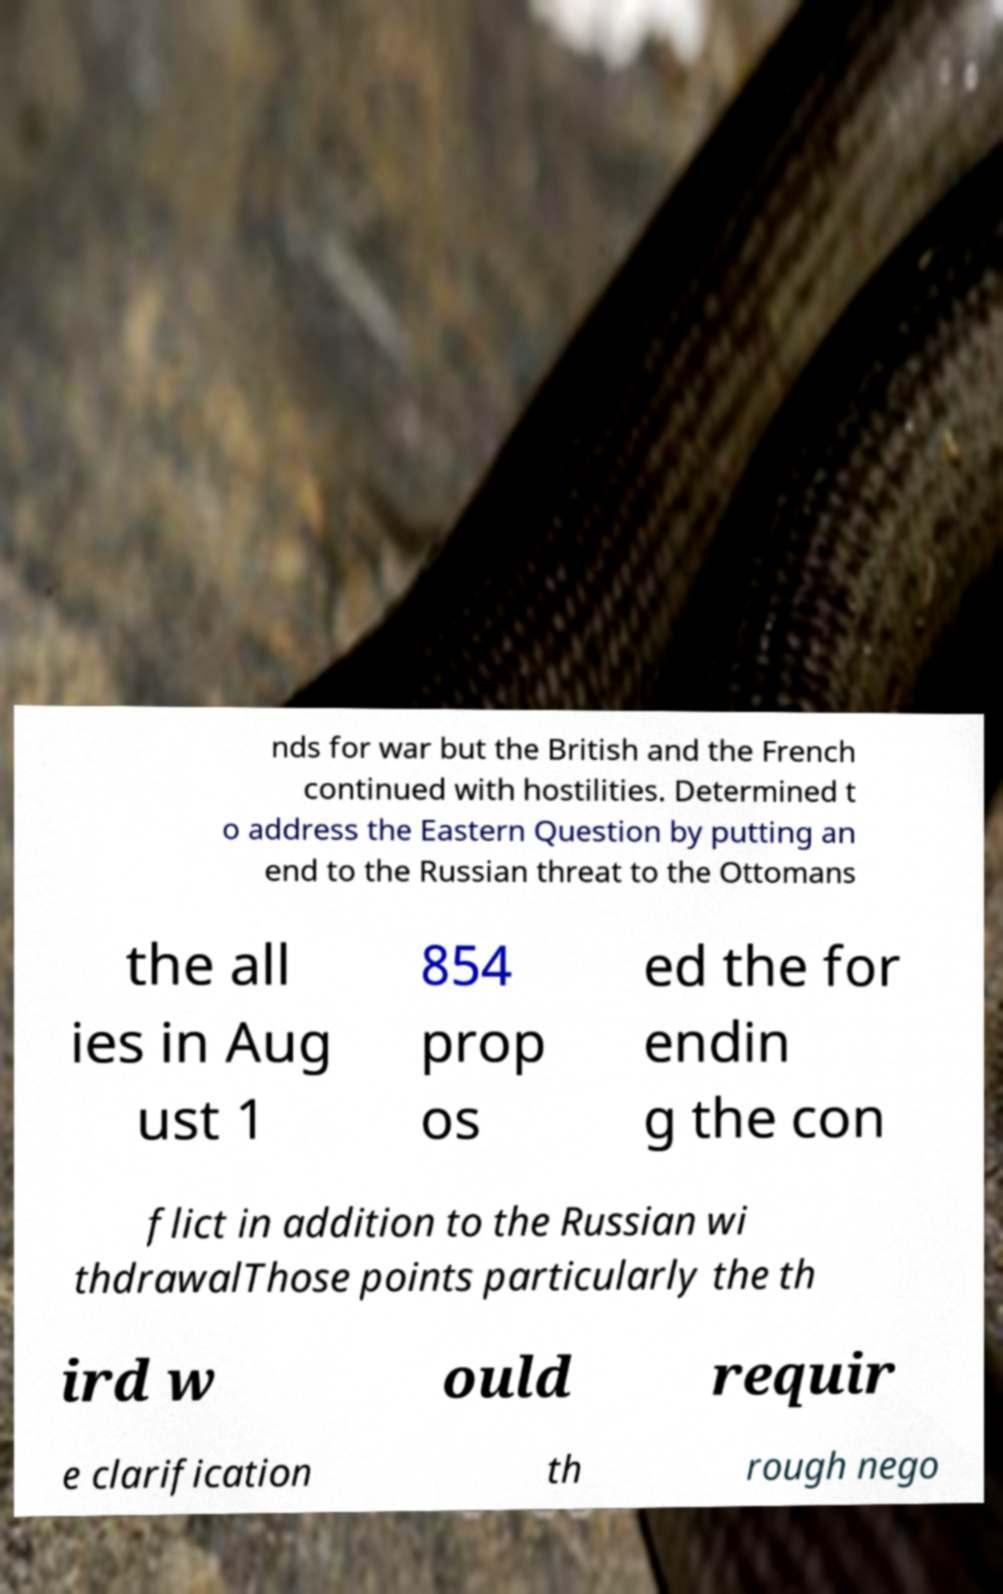What messages or text are displayed in this image? I need them in a readable, typed format. nds for war but the British and the French continued with hostilities. Determined t o address the Eastern Question by putting an end to the Russian threat to the Ottomans the all ies in Aug ust 1 854 prop os ed the for endin g the con flict in addition to the Russian wi thdrawalThose points particularly the th ird w ould requir e clarification th rough nego 